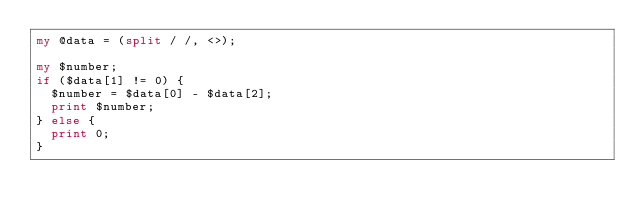<code> <loc_0><loc_0><loc_500><loc_500><_Perl_>my @data = (split / /, <>);

my $number;
if ($data[1] != 0) {
  $number = $data[0] - $data[2];
  print $number;
} else {
  print 0;
}</code> 